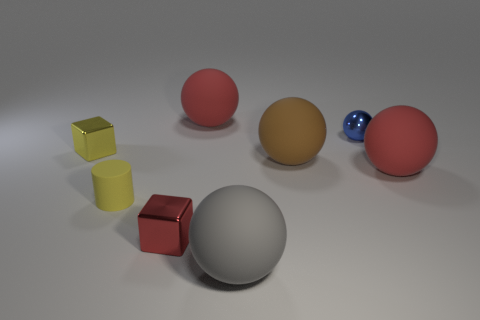Are there any big red rubber objects of the same shape as the large gray rubber object?
Your answer should be very brief. Yes. Is the number of yellow metallic blocks that are behind the brown ball greater than the number of big gray shiny spheres?
Offer a very short reply. Yes. Do the matte cylinder and the small cube behind the brown rubber ball have the same color?
Offer a terse response. Yes. Are there the same number of yellow cubes right of the small rubber object and gray balls that are in front of the gray object?
Your answer should be compact. Yes. What material is the large sphere that is behind the blue sphere?
Your answer should be compact. Rubber. What number of objects are either matte spheres that are in front of the small red metallic cube or big spheres?
Ensure brevity in your answer.  4. How many other things are there of the same shape as the large brown object?
Offer a terse response. 4. Does the large red matte object in front of the shiny ball have the same shape as the large brown rubber thing?
Ensure brevity in your answer.  Yes. There is a tiny yellow cube; are there any tiny yellow rubber cylinders left of it?
Offer a terse response. No. How many big things are either cyan metal cubes or cubes?
Your answer should be compact. 0. 